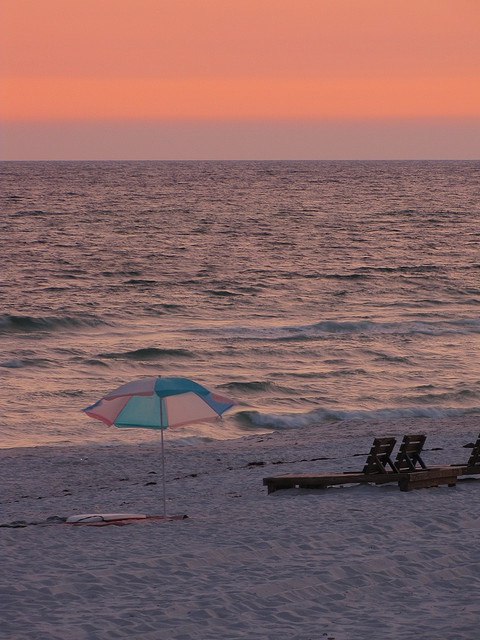Describe the objects in this image and their specific colors. I can see umbrella in salmon, gray, blue, and purple tones, chair in salmon, black, and gray tones, and chair in salmon, black, and gray tones in this image. 